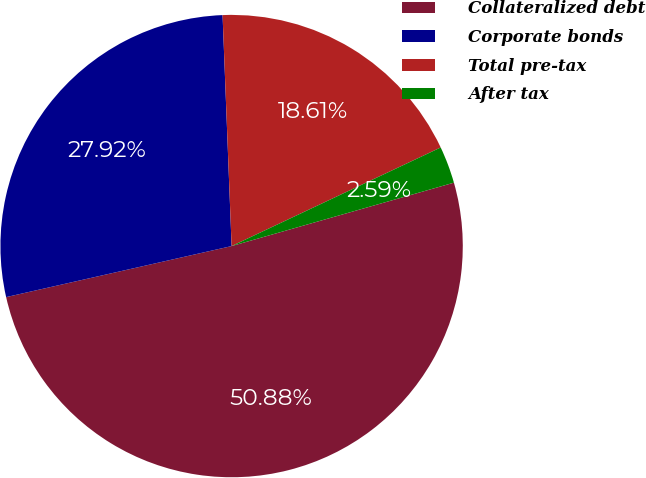Convert chart. <chart><loc_0><loc_0><loc_500><loc_500><pie_chart><fcel>Collateralized debt<fcel>Corporate bonds<fcel>Total pre-tax<fcel>After tax<nl><fcel>50.88%<fcel>27.92%<fcel>18.61%<fcel>2.59%<nl></chart> 